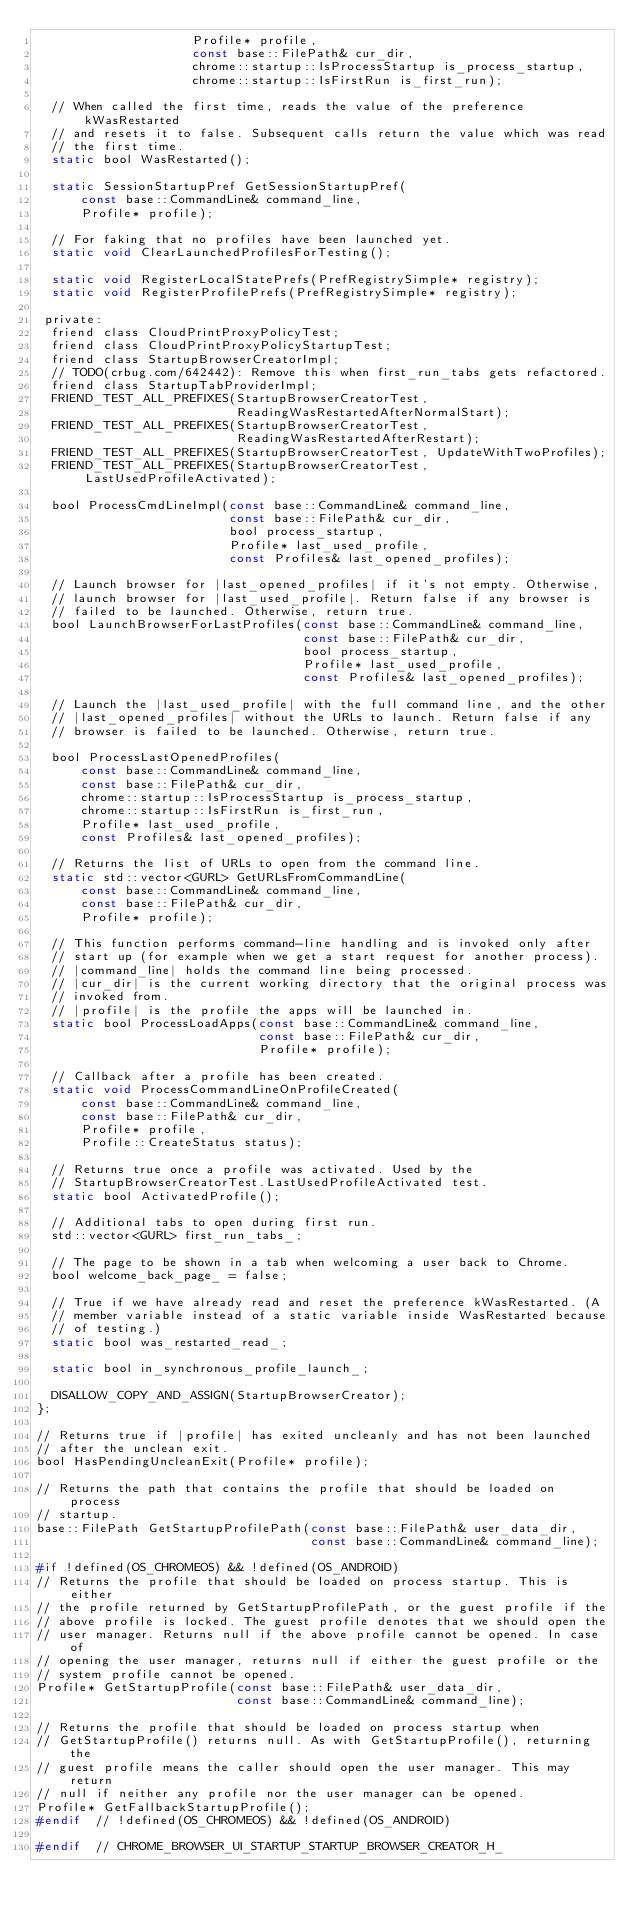Convert code to text. <code><loc_0><loc_0><loc_500><loc_500><_C_>                     Profile* profile,
                     const base::FilePath& cur_dir,
                     chrome::startup::IsProcessStartup is_process_startup,
                     chrome::startup::IsFirstRun is_first_run);

  // When called the first time, reads the value of the preference kWasRestarted
  // and resets it to false. Subsequent calls return the value which was read
  // the first time.
  static bool WasRestarted();

  static SessionStartupPref GetSessionStartupPref(
      const base::CommandLine& command_line,
      Profile* profile);

  // For faking that no profiles have been launched yet.
  static void ClearLaunchedProfilesForTesting();

  static void RegisterLocalStatePrefs(PrefRegistrySimple* registry);
  static void RegisterProfilePrefs(PrefRegistrySimple* registry);

 private:
  friend class CloudPrintProxyPolicyTest;
  friend class CloudPrintProxyPolicyStartupTest;
  friend class StartupBrowserCreatorImpl;
  // TODO(crbug.com/642442): Remove this when first_run_tabs gets refactored.
  friend class StartupTabProviderImpl;
  FRIEND_TEST_ALL_PREFIXES(StartupBrowserCreatorTest,
                           ReadingWasRestartedAfterNormalStart);
  FRIEND_TEST_ALL_PREFIXES(StartupBrowserCreatorTest,
                           ReadingWasRestartedAfterRestart);
  FRIEND_TEST_ALL_PREFIXES(StartupBrowserCreatorTest, UpdateWithTwoProfiles);
  FRIEND_TEST_ALL_PREFIXES(StartupBrowserCreatorTest, LastUsedProfileActivated);

  bool ProcessCmdLineImpl(const base::CommandLine& command_line,
                          const base::FilePath& cur_dir,
                          bool process_startup,
                          Profile* last_used_profile,
                          const Profiles& last_opened_profiles);

  // Launch browser for |last_opened_profiles| if it's not empty. Otherwise,
  // launch browser for |last_used_profile|. Return false if any browser is
  // failed to be launched. Otherwise, return true.
  bool LaunchBrowserForLastProfiles(const base::CommandLine& command_line,
                                    const base::FilePath& cur_dir,
                                    bool process_startup,
                                    Profile* last_used_profile,
                                    const Profiles& last_opened_profiles);

  // Launch the |last_used_profile| with the full command line, and the other
  // |last_opened_profiles| without the URLs to launch. Return false if any
  // browser is failed to be launched. Otherwise, return true.

  bool ProcessLastOpenedProfiles(
      const base::CommandLine& command_line,
      const base::FilePath& cur_dir,
      chrome::startup::IsProcessStartup is_process_startup,
      chrome::startup::IsFirstRun is_first_run,
      Profile* last_used_profile,
      const Profiles& last_opened_profiles);

  // Returns the list of URLs to open from the command line.
  static std::vector<GURL> GetURLsFromCommandLine(
      const base::CommandLine& command_line,
      const base::FilePath& cur_dir,
      Profile* profile);

  // This function performs command-line handling and is invoked only after
  // start up (for example when we get a start request for another process).
  // |command_line| holds the command line being processed.
  // |cur_dir| is the current working directory that the original process was
  // invoked from.
  // |profile| is the profile the apps will be launched in.
  static bool ProcessLoadApps(const base::CommandLine& command_line,
                              const base::FilePath& cur_dir,
                              Profile* profile);

  // Callback after a profile has been created.
  static void ProcessCommandLineOnProfileCreated(
      const base::CommandLine& command_line,
      const base::FilePath& cur_dir,
      Profile* profile,
      Profile::CreateStatus status);

  // Returns true once a profile was activated. Used by the
  // StartupBrowserCreatorTest.LastUsedProfileActivated test.
  static bool ActivatedProfile();

  // Additional tabs to open during first run.
  std::vector<GURL> first_run_tabs_;

  // The page to be shown in a tab when welcoming a user back to Chrome.
  bool welcome_back_page_ = false;

  // True if we have already read and reset the preference kWasRestarted. (A
  // member variable instead of a static variable inside WasRestarted because
  // of testing.)
  static bool was_restarted_read_;

  static bool in_synchronous_profile_launch_;

  DISALLOW_COPY_AND_ASSIGN(StartupBrowserCreator);
};

// Returns true if |profile| has exited uncleanly and has not been launched
// after the unclean exit.
bool HasPendingUncleanExit(Profile* profile);

// Returns the path that contains the profile that should be loaded on process
// startup.
base::FilePath GetStartupProfilePath(const base::FilePath& user_data_dir,
                                     const base::CommandLine& command_line);

#if !defined(OS_CHROMEOS) && !defined(OS_ANDROID)
// Returns the profile that should be loaded on process startup. This is either
// the profile returned by GetStartupProfilePath, or the guest profile if the
// above profile is locked. The guest profile denotes that we should open the
// user manager. Returns null if the above profile cannot be opened. In case of
// opening the user manager, returns null if either the guest profile or the
// system profile cannot be opened.
Profile* GetStartupProfile(const base::FilePath& user_data_dir,
                           const base::CommandLine& command_line);

// Returns the profile that should be loaded on process startup when
// GetStartupProfile() returns null. As with GetStartupProfile(), returning the
// guest profile means the caller should open the user manager. This may return
// null if neither any profile nor the user manager can be opened.
Profile* GetFallbackStartupProfile();
#endif  // !defined(OS_CHROMEOS) && !defined(OS_ANDROID)

#endif  // CHROME_BROWSER_UI_STARTUP_STARTUP_BROWSER_CREATOR_H_
</code> 